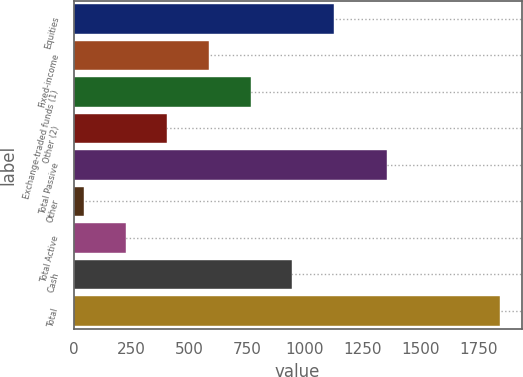<chart> <loc_0><loc_0><loc_500><loc_500><bar_chart><fcel>Equities<fcel>Fixed-income<fcel>Exchange-traded funds (1)<fcel>Other (2)<fcel>Total Passive<fcel>Other<fcel>Total Active<fcel>Cash<fcel>Total<nl><fcel>1125<fcel>585<fcel>765<fcel>405<fcel>1353<fcel>45<fcel>225<fcel>945<fcel>1845<nl></chart> 